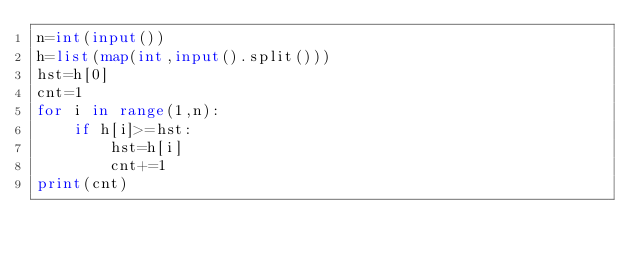<code> <loc_0><loc_0><loc_500><loc_500><_Python_>n=int(input())
h=list(map(int,input().split()))
hst=h[0]
cnt=1
for i in range(1,n):
    if h[i]>=hst:
        hst=h[i]
        cnt+=1
print(cnt)
</code> 